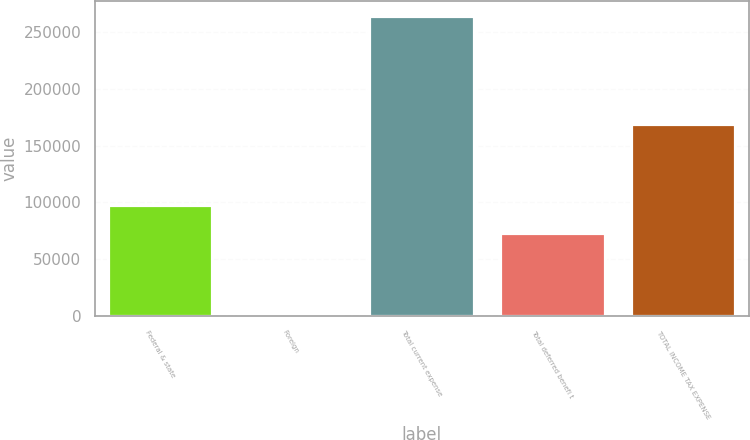<chart> <loc_0><loc_0><loc_500><loc_500><bar_chart><fcel>Federal & state<fcel>Foreign<fcel>Total current expense<fcel>Total deferred benefi t<fcel>TOTAL INCOME TAX EXPENSE<nl><fcel>97411.9<fcel>2727<fcel>263801<fcel>73430<fcel>169116<nl></chart> 